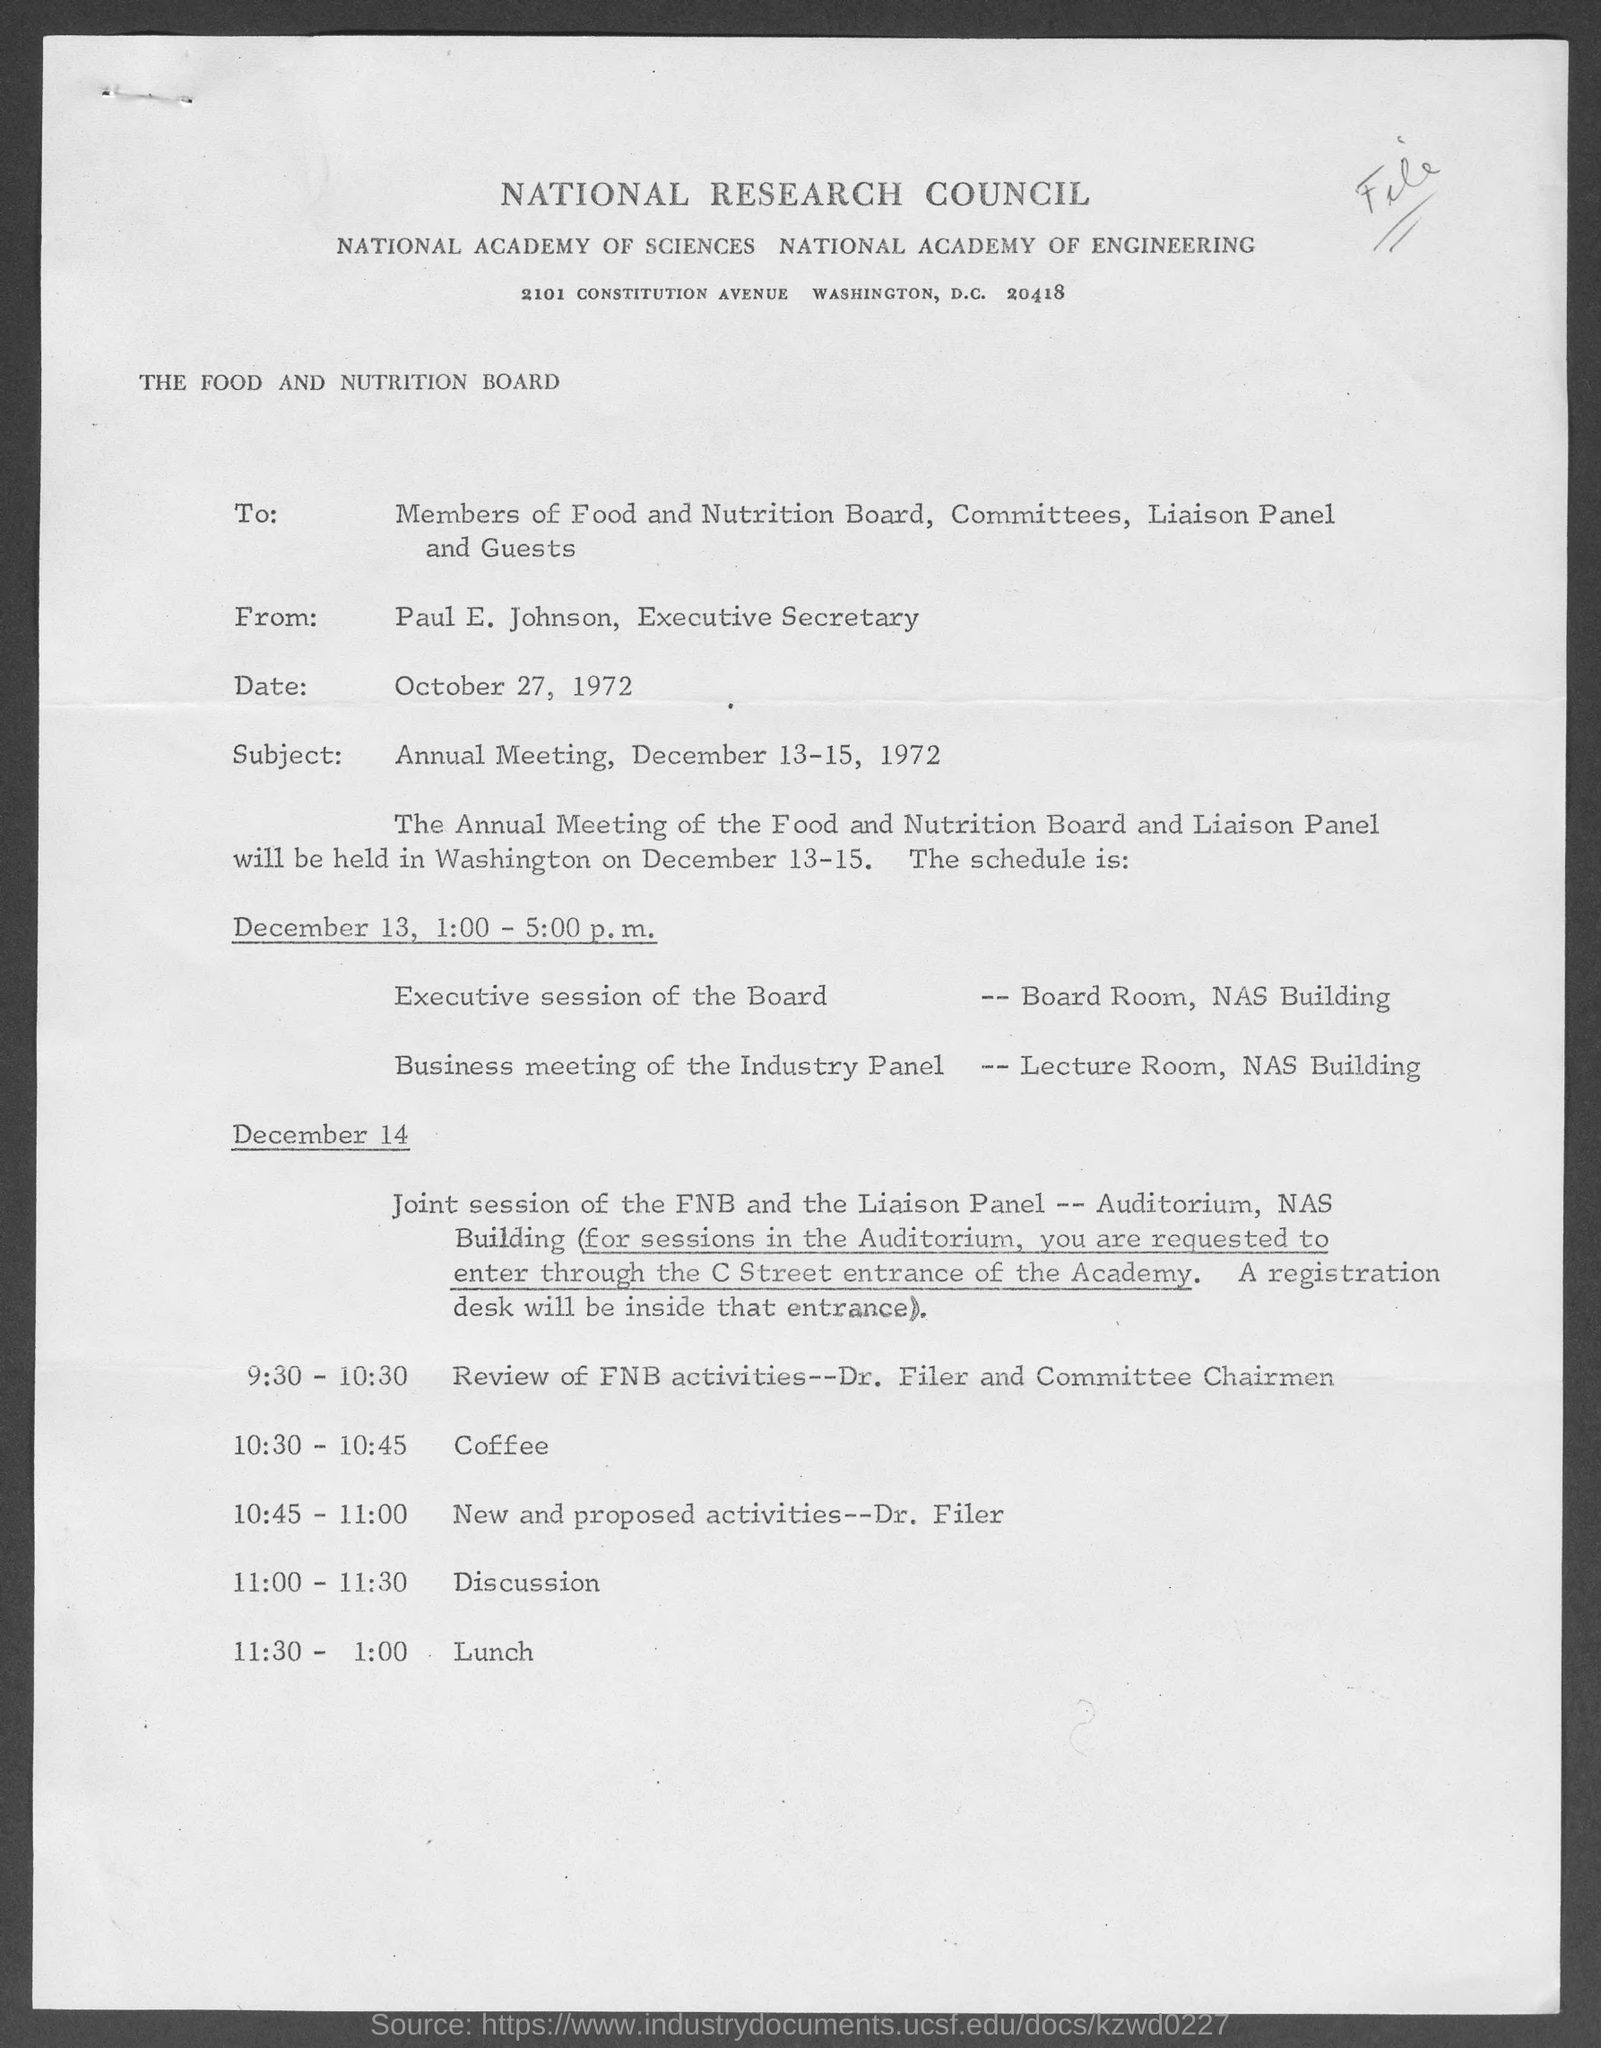Who is the executive secretary of national research council?
Make the answer very short. Paul E. Johnson. What time is scheduled for discussion on december 14?
Keep it short and to the point. 11:00-11:30. What time is scheduled for review of fnb activities?
Your response must be concise. 9:30-10:30. What is the subject of the letter?
Your answer should be compact. Annual meeting. 